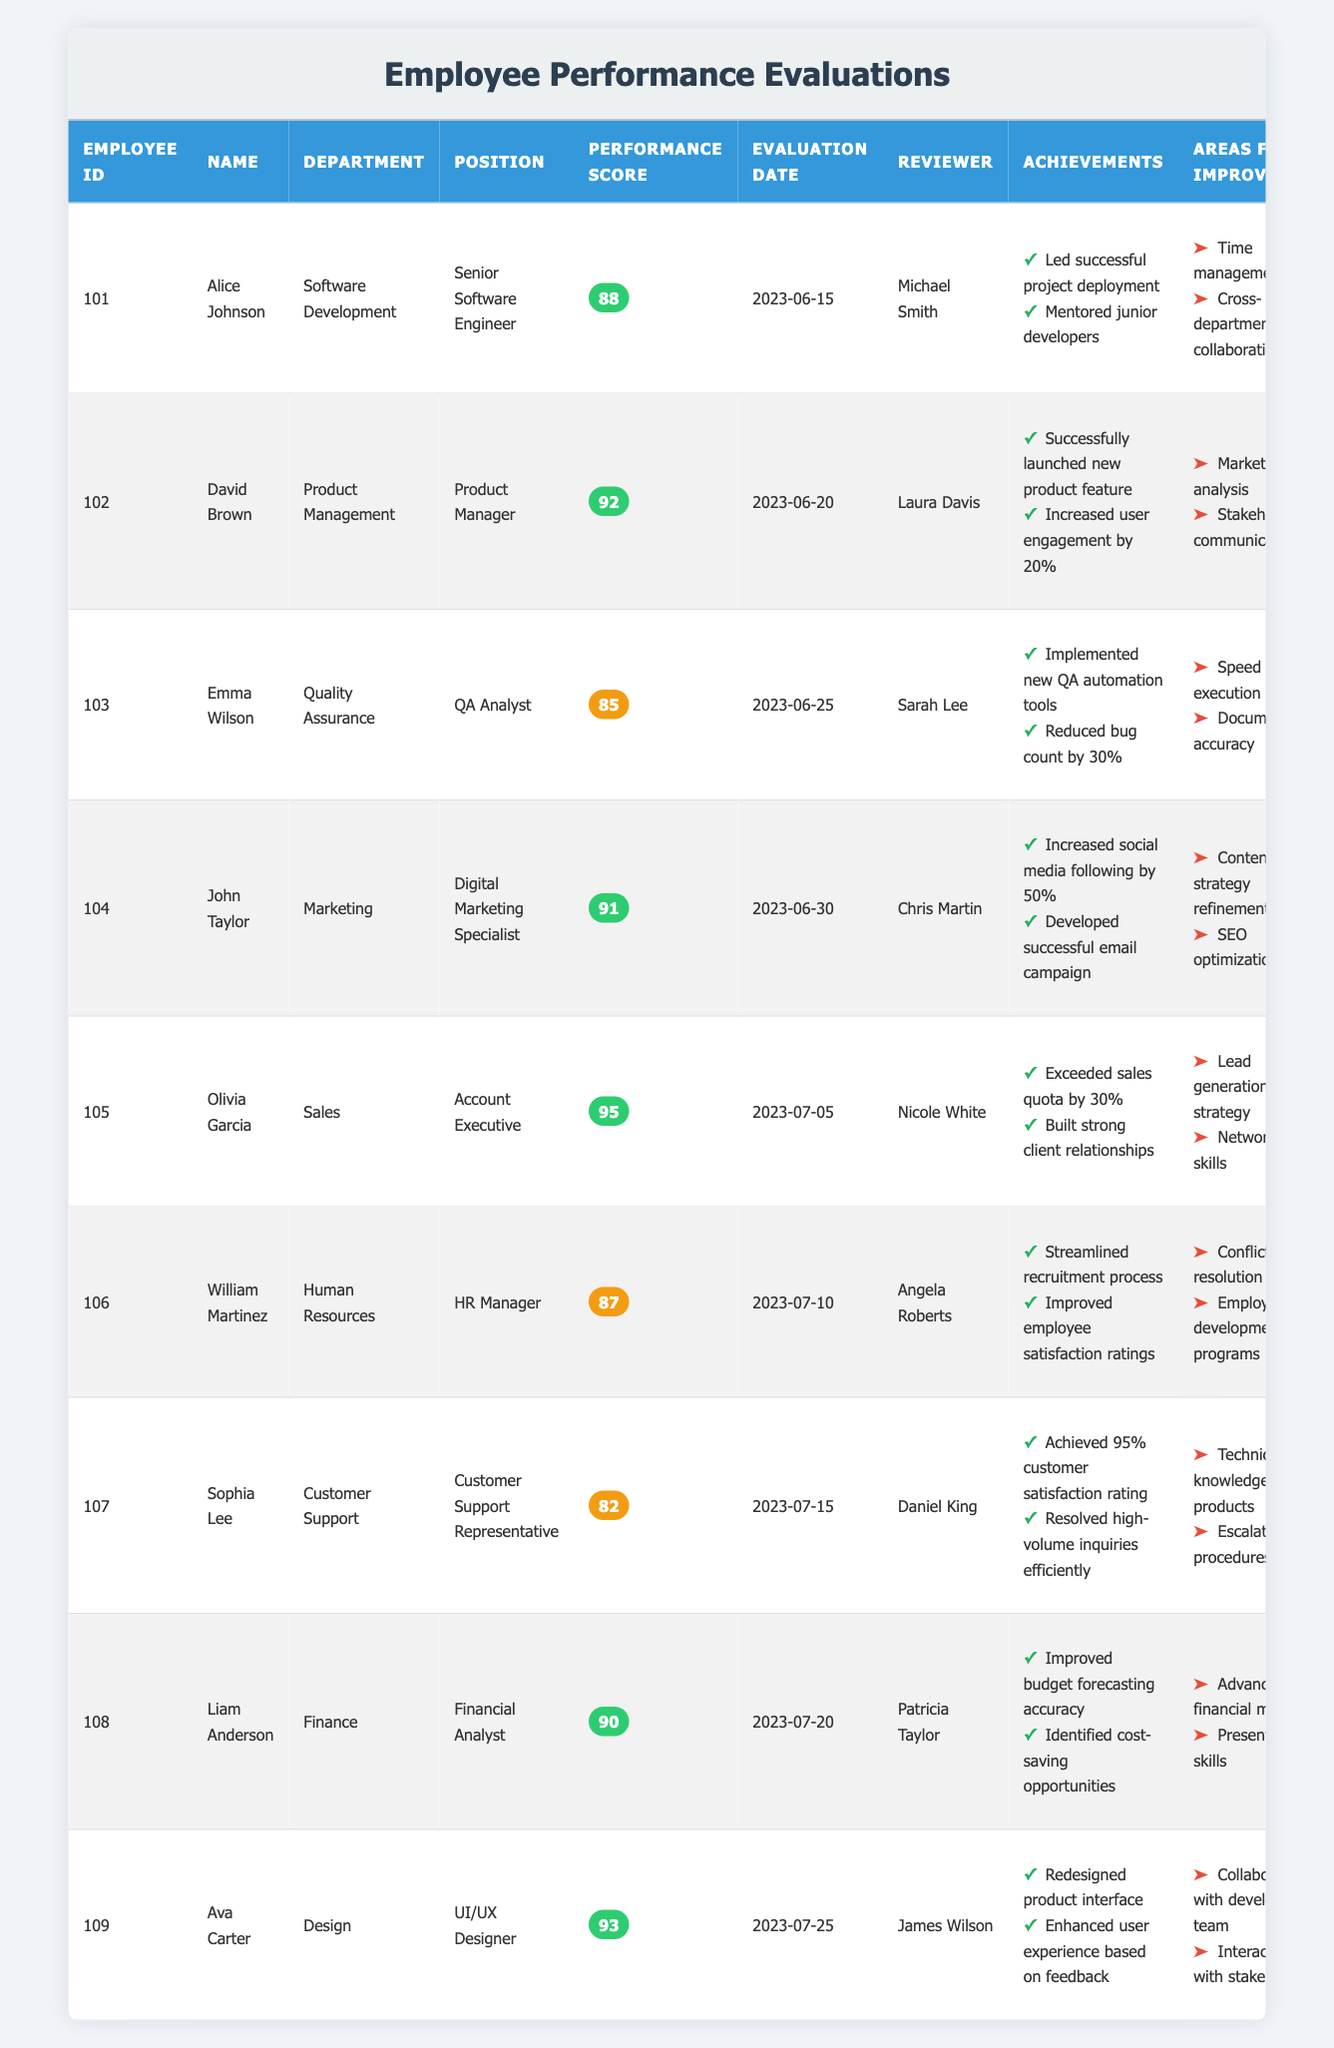What is the performance score of Emma Wilson? The performance score of Emma Wilson is listed in the table under the "Performance Score" column, where her score is explicitly stated as 85.
Answer: 85 Which employee achieved the highest performance score and what was it? The employee with the highest performance score is Olivia Garcia, with a score of 95. This can be determined by comparing all performance scores in the table.
Answer: 95 Are there any employees with a performance score below 85? Yes, Sophia Lee has a performance score of 82, which is below 85. This is assessed by checking the "Performance Score" column for scores lower than 85.
Answer: Yes What are the areas for improvement for John Taylor? John Taylor's areas for improvement are listed in the respective column and include "Content strategy refinement" and "SEO optimization skills." Both points can be directly found under his entry in the table.
Answer: Content strategy refinement, SEO optimization skills What is the average performance score for the Software Development department? The performance scores for the Software Development department are: 88 (Alice Johnson). The average is calculated by taking the total (88) and dividing it by the number of employees (1), resulting in 88.
Answer: 88 Which department had two employees with performance scores of 90 or above? The departments of Product Management (David Brown - 92) and Sales (Olivia Garcia - 95) both had employees with performance scores of 90 or above. This can be determined by filtering through the table to find departments with qualifying scores.
Answer: Product Management, Sales What percentage of employees received a performance score of 90 or higher? There are 5 employees with performance scores of 90 or higher (David Brown, Olivia Garcia, Liam Anderson, Ava Carter). With 9 employees total, the percentage is calculated as (5/9) * 100, which equals approximately 55.56%.
Answer: 55.56% Was there an employee who started their evaluation process before June 20, 2023, and what was their score? Yes, Alice Johnson's evaluation date is June 15, 2023, and her performance score is 88. This is confirmed by checking the "Evaluation Date" column for the relevant dates and extracting her performance score from the table entry.
Answer: 88 What are the achievements of Liam Anderson? Liam Anderson's achievements are documented and include "Improved budget forecasting accuracy" and "Identified cost-saving opportunities." These achievements can be found listed under his name in the achievements column.
Answer: Improved budget forecasting accuracy, Identified cost-saving opportunities 